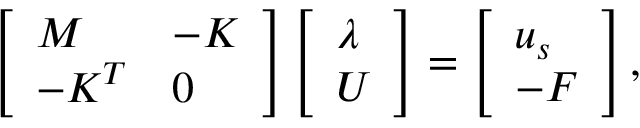<formula> <loc_0><loc_0><loc_500><loc_500>\begin{array} { r } { \left [ \begin{array} { l l } { M } & { - K } \\ { - K ^ { T } } & { 0 } \end{array} \right ] \left [ \begin{array} { l } { \lambda } \\ { U } \end{array} \right ] = \left [ \begin{array} { l } { u _ { s } } \\ { - F } \end{array} \right ] , } \end{array}</formula> 